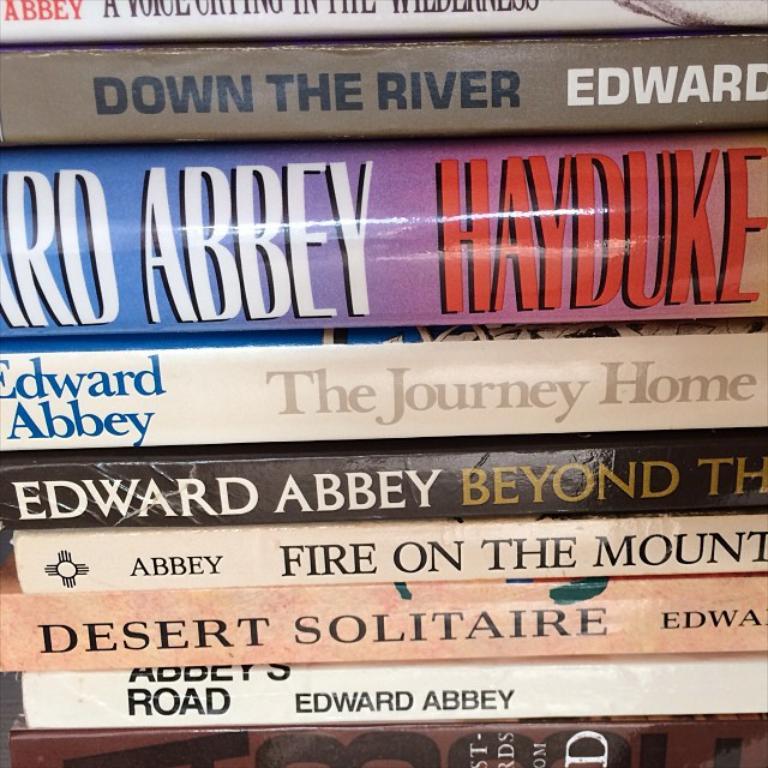Who is the author of these books?
Your answer should be compact. Edward abbey. 